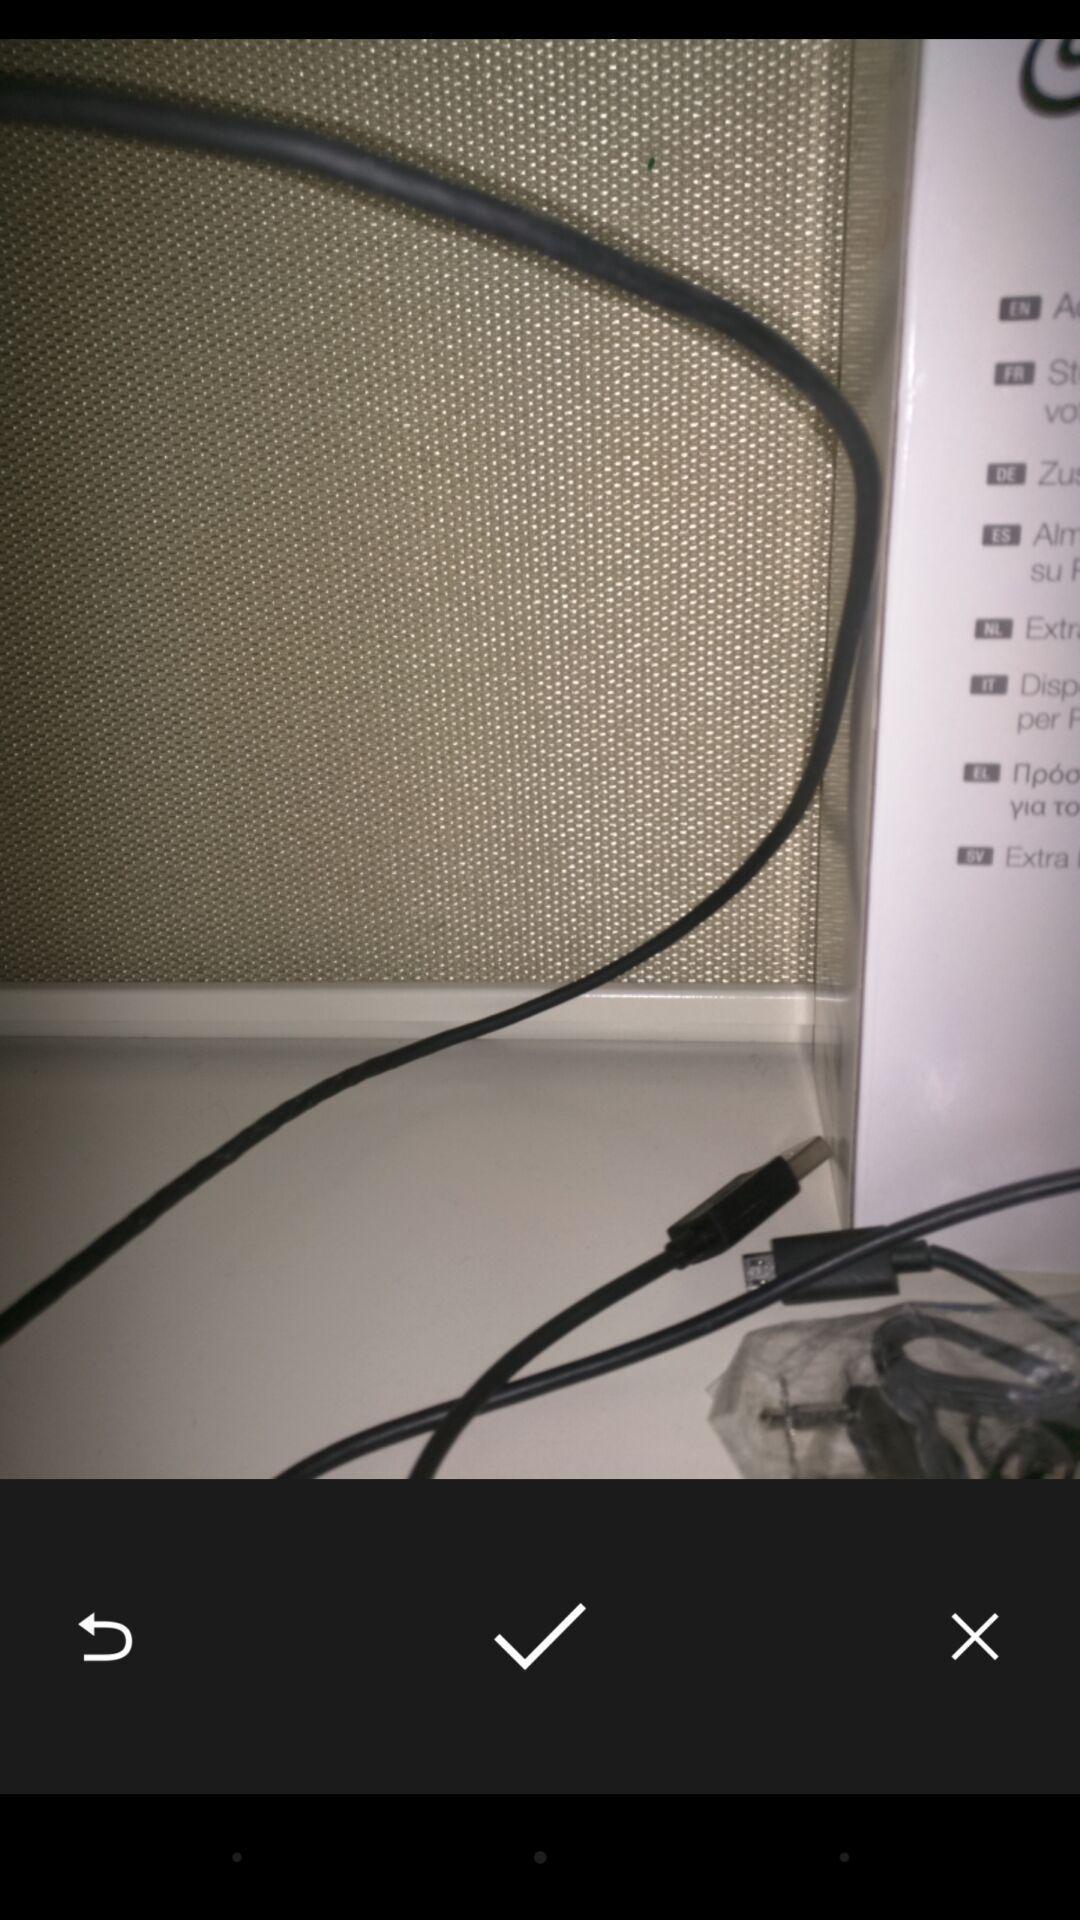Please provide a description for this image. Screen displaying picture of cable wires. 